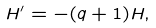Convert formula to latex. <formula><loc_0><loc_0><loc_500><loc_500>H ^ { \prime } = - ( q + 1 ) H ,</formula> 